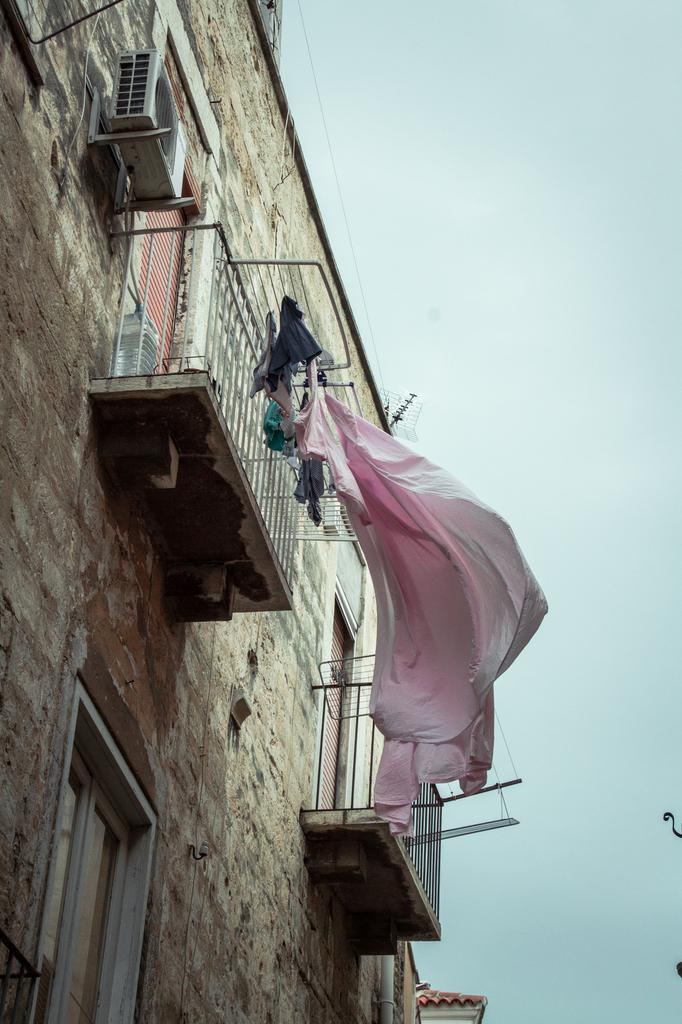What type of structure is in the image? There is a building in the image. What feature of the building is mentioned in the facts? The building has windows. Can you describe any outdoor features in the image? There is a balcony in the image. What can be seen hanging or placed outside in the image? Clothes are visible in the image. What is visible in the background of the image? The sky is visible in the image, and clouds are present in the sky. Where is the air conditioning unit located in the image? There is a split AC in the top left corner of the image. How many trees are visible on the balcony in the image? There are no trees visible on the balcony in the image. What type of plants can be seen growing on the clothes in the image? There are no plants visible on the clothes in the image. 